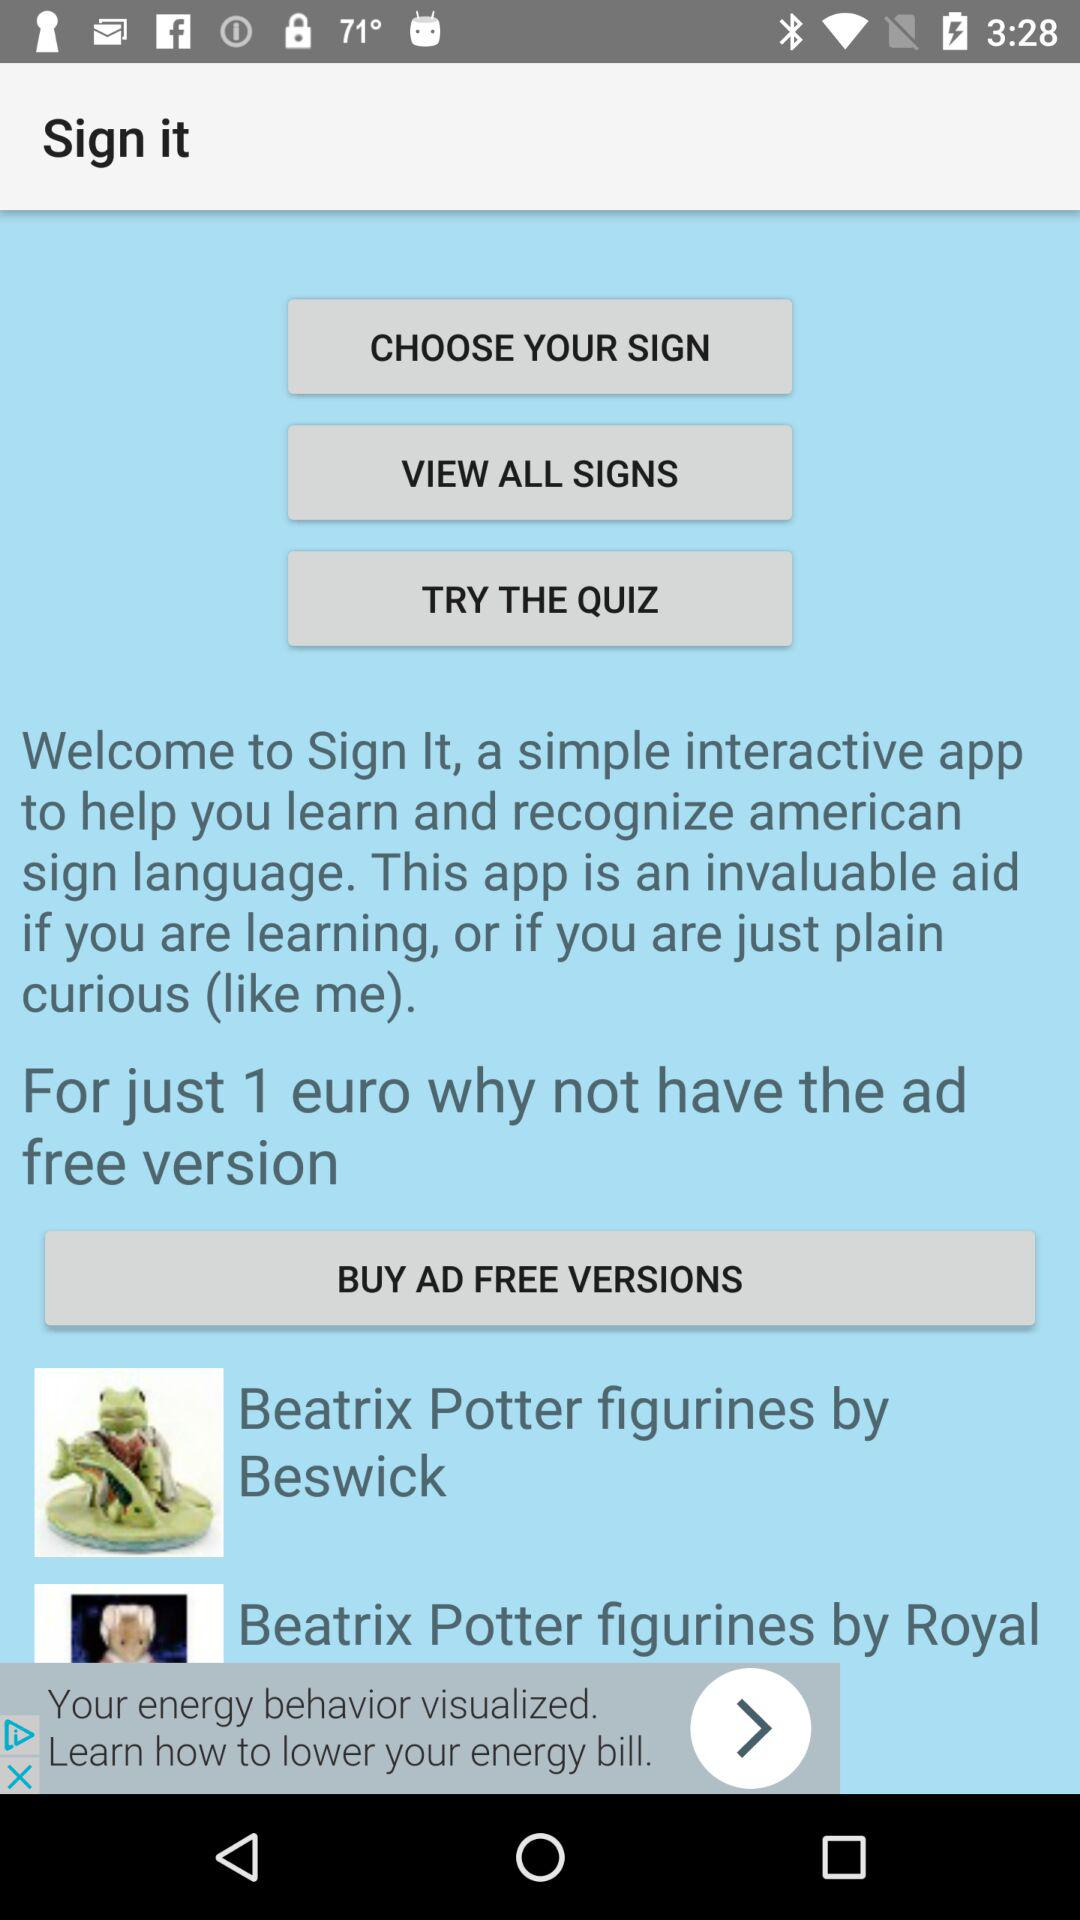What is the app name? The app name is "Sign It". 